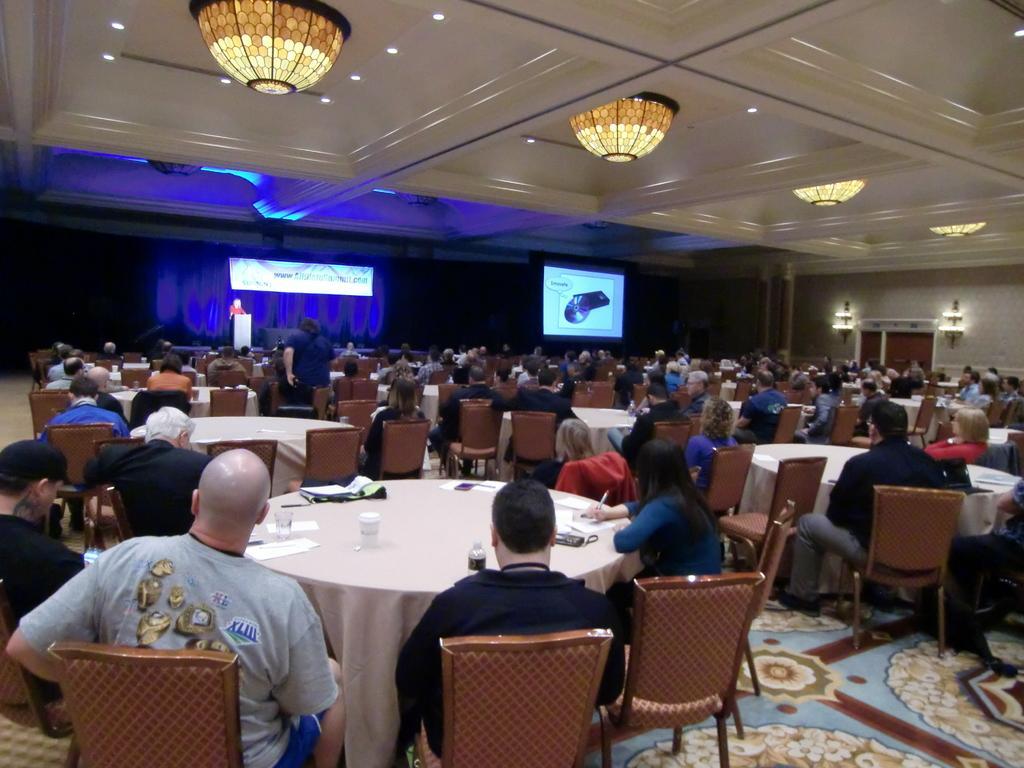In one or two sentences, can you explain what this image depicts? In this image i can see number of people sitting on chairs in front of tables, On the tables i can see few glasses, few bottles and few papers. In the background i can see a stage on which there is a podium and a person behind it , a curtain , a screen and a projector. To the top of the image i can see the ceiling and few lights. 